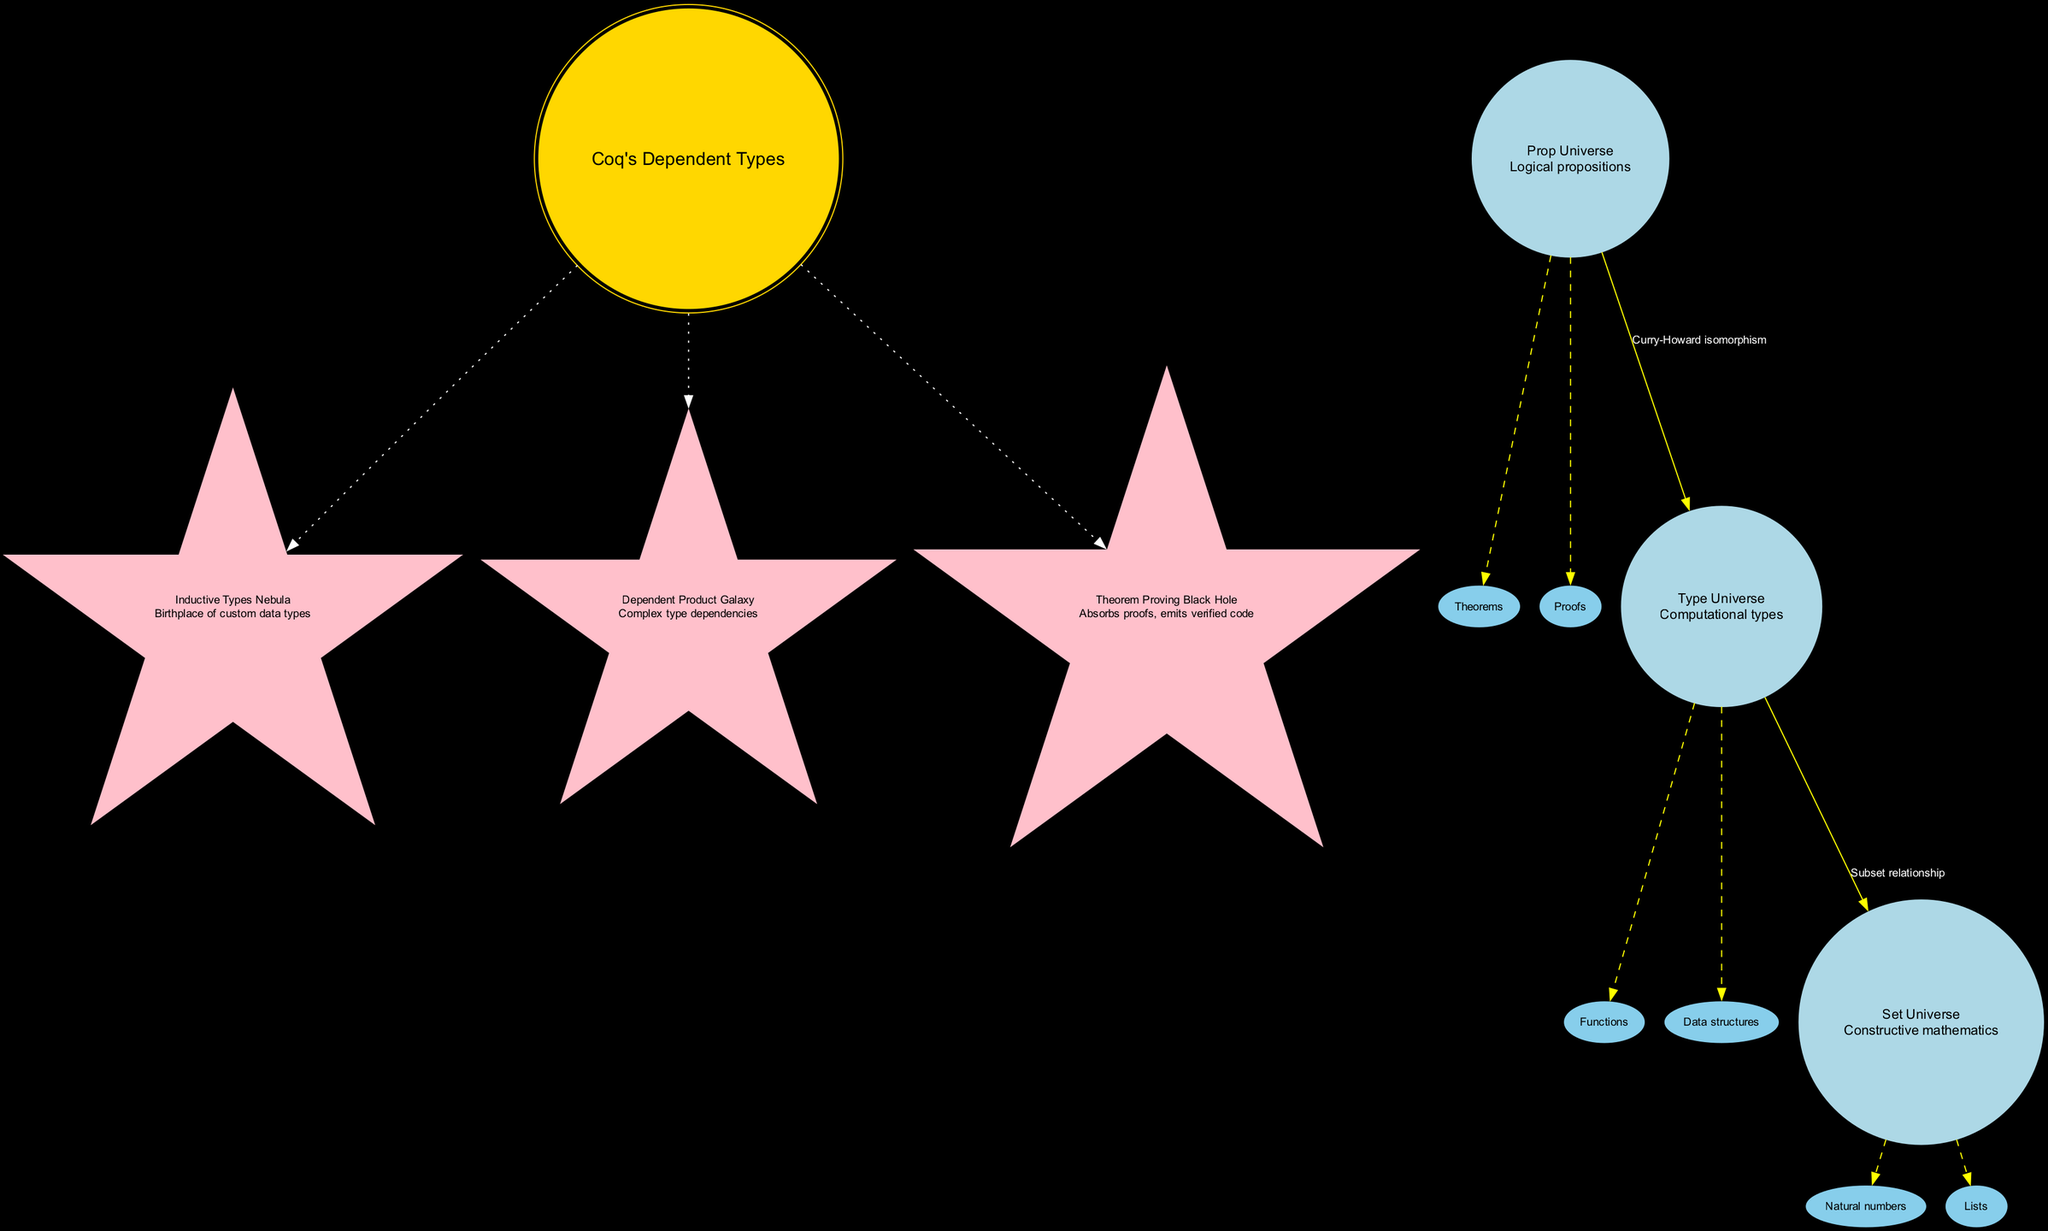What is the central concept of the diagram? The central concept is explicitly labeled as "Coq's Dependent Types" in a distinct shape and color at the center of the diagram.
Answer: Coq's Dependent Types How many celestial bodies are depicted in the diagram? By counting the celestial bodies listed under the 'celestial_bodies' key, we identify three distinct entities: Prop Universe, Type Universe, and Set Universe.
Answer: 3 What is the label on the connection from Prop Universe to Type Universe? The connection between these two nodes is labeled "Curry-Howard isomorphism," which is visible on the edge connecting them.
Answer: Curry-Howard isomorphism Which cosmic phenomenon is described as "Absorbs proofs, emits verified code"? This description directly relates to the "Theorem Proving Black Hole," which is labeled with this specific description in the diagram.
Answer: Theorem Proving Black Hole What type of relationship is described between Type Universe and Set Universe? The relationship is labeled as "Subset relationship," indicating a particular type of connection that is visually depicted on the connecting edge.
Answer: Subset relationship How many sub-elements are associated with the Prop Universe? The Prop Universe has two sub-elements listed: Theorems and Proofs. Counting these gives us the total number of associated sub-elements.
Answer: 2 Which node represents "Complex type dependencies"? This description corresponds to the node "Dependent Product Galaxy," which indicates its relationship with complex dependencies in types.
Answer: Dependent Product Galaxy Is there a connection between the central concept and the Inductive Types Nebula? Yes, there is a dotted edge connecting the central concept to the Inductive Types Nebula, indicating a relationship between them.
Answer: Yes What shape represents cosmic phenomena in the diagram? The nodes representing cosmic phenomena are shaped like stars, which is distinctive in the diagram as compared to other node shapes.
Answer: Star 